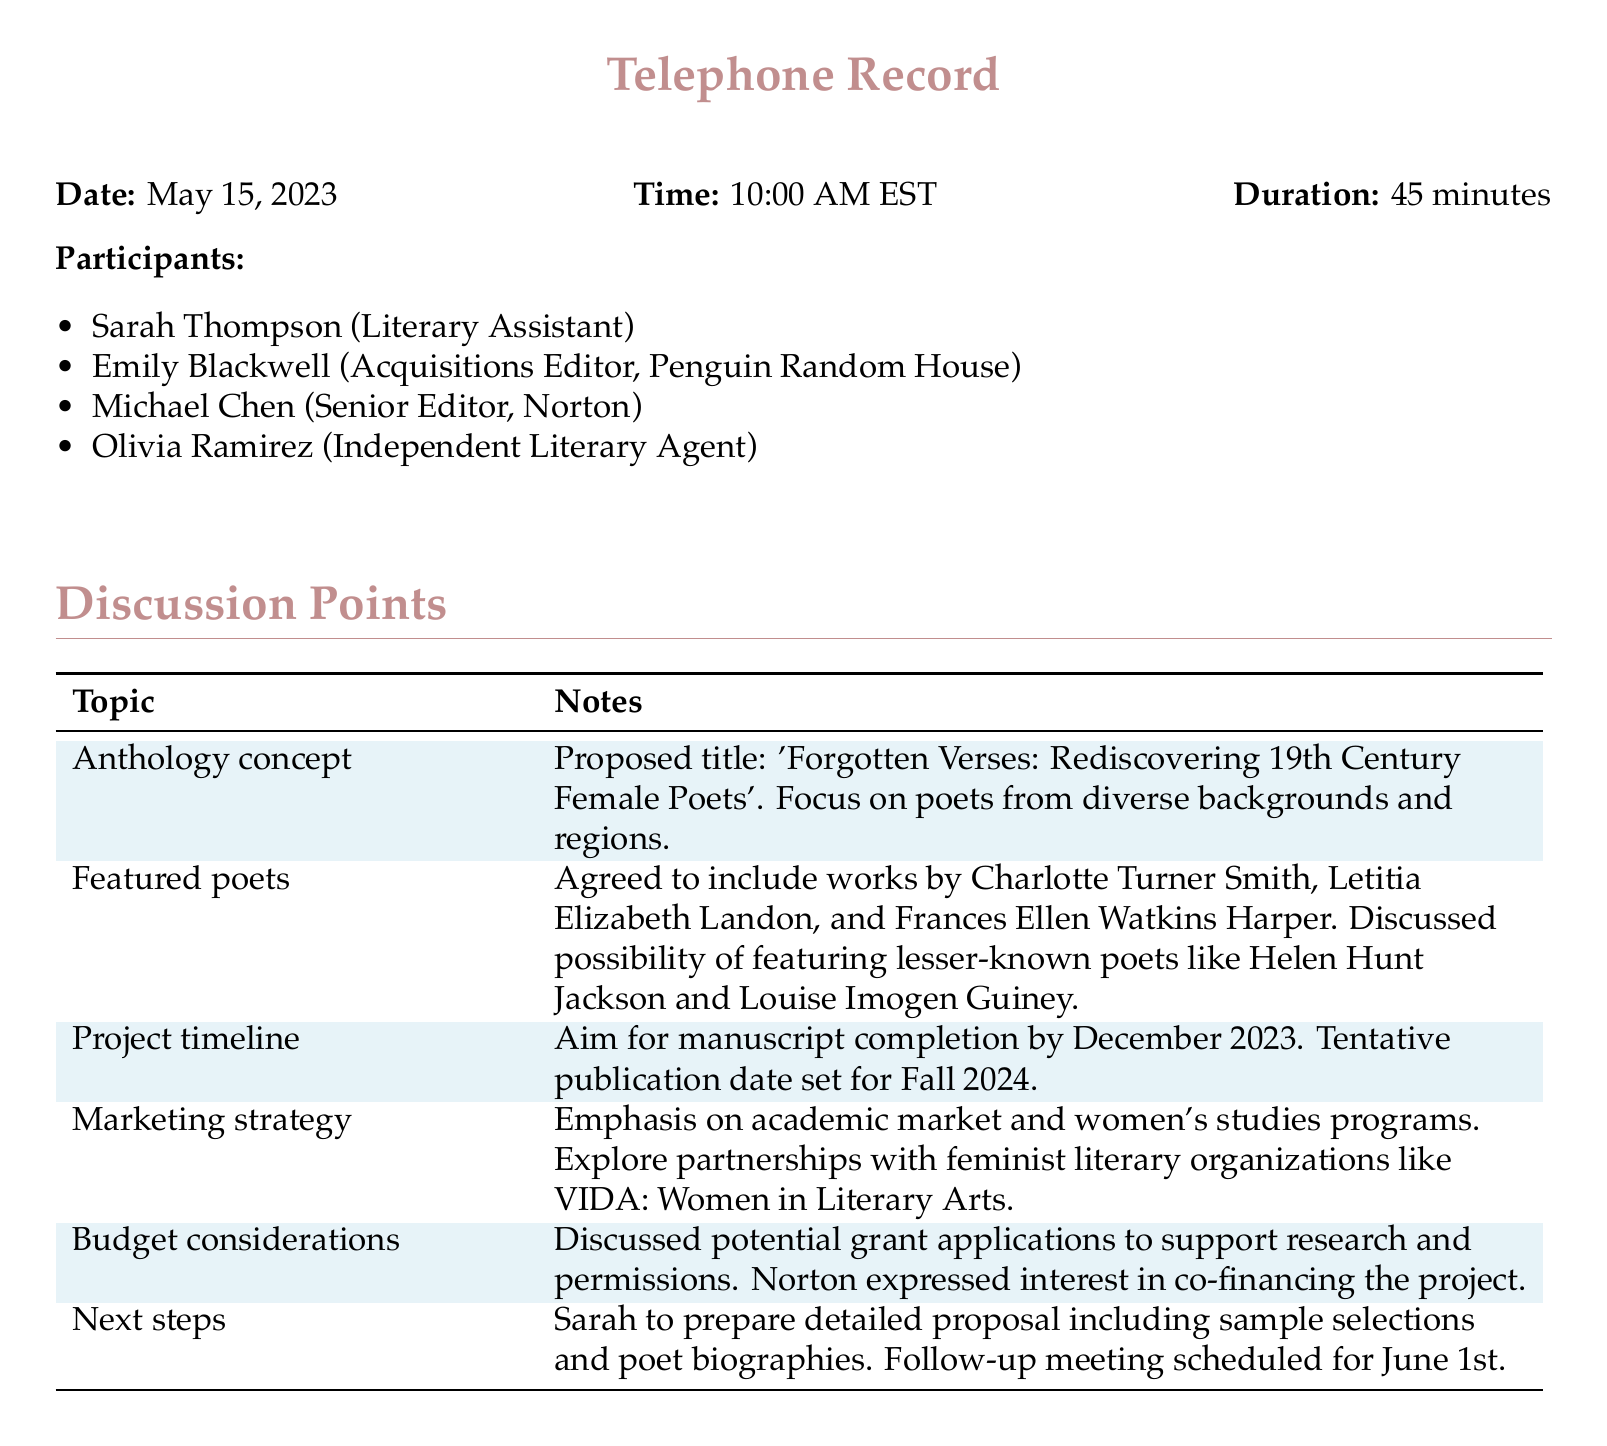what is the proposed title of the anthology? The proposed title is the name suggested during the call, which is 'Forgotten Verses: Rediscovering 19th Century Female Poets'.
Answer: 'Forgotten Verses: Rediscovering 19th Century Female Poets' who is the Acquisitions Editor from Penguin Random House? The Acquisitions Editor is mentioned as a participant in the call and is Emily Blackwell.
Answer: Emily Blackwell what is the target completion date for the manuscript? The target completion date for the manuscript is stated in the discussion points and is December 2023.
Answer: December 2023 which poet's works were agreed to be included in the anthology? Several poets were mentioned, including Charlotte Turner Smith, Letitia Elizabeth Landon, and Frances Ellen Watkins Harper.
Answer: Charlotte Turner Smith, Letitia Elizabeth Landon, Frances Ellen Watkins Harper when is the follow-up meeting scheduled? The date of the follow-up meeting is specified in the notes and is June 1st.
Answer: June 1st what is the tentative publication date set for the anthology? The tentative publication date is noted in the discussion points and is Fall 2024.
Answer: Fall 2024 which organization was suggested for partnerships in the marketing strategy? The organization mentioned for partnerships is VIDA: Women in Literary Arts.
Answer: VIDA: Women in Literary Arts who is responsible for preparing a detailed proposal? The individual assigned to prepare a detailed proposal is identified in the notes as Sarah.
Answer: Sarah 